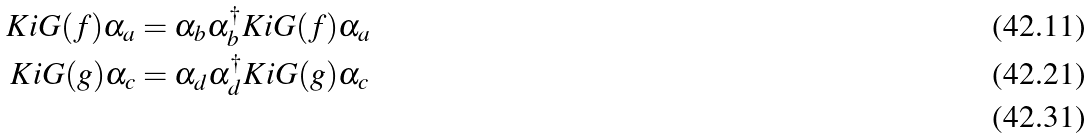Convert formula to latex. <formula><loc_0><loc_0><loc_500><loc_500>K i G ( f ) \alpha _ { a } & = \alpha _ { b } \alpha _ { b } ^ { \dagger } K i G ( f ) \alpha _ { a } \\ K i G ( g ) \alpha _ { c } & = \alpha _ { d } \alpha _ { d } ^ { \dagger } K i G ( g ) \alpha _ { c } \\</formula> 